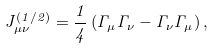<formula> <loc_0><loc_0><loc_500><loc_500>J _ { \mu \nu } ^ { ( 1 / 2 ) } = \frac { 1 } { 4 } \left ( \Gamma _ { \mu } \Gamma _ { \nu } - \Gamma _ { \nu } \Gamma _ { \mu } \right ) ,</formula> 